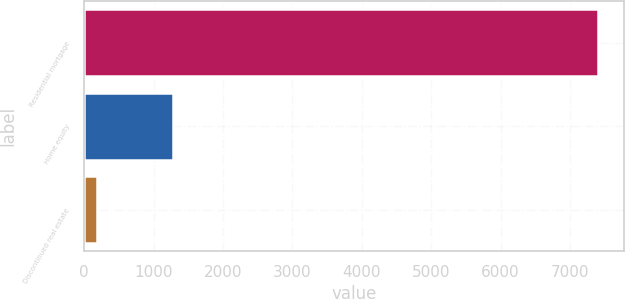Convert chart. <chart><loc_0><loc_0><loc_500><loc_500><bar_chart><fcel>Residential mortgage<fcel>Home equity<fcel>Discontinued real estate<nl><fcel>7406<fcel>1284<fcel>177<nl></chart> 